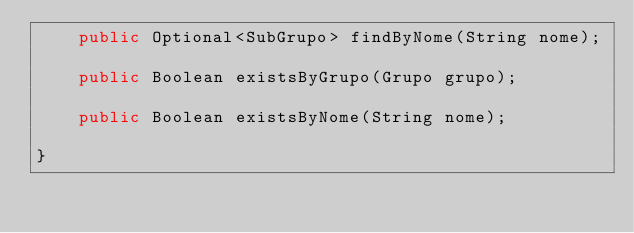<code> <loc_0><loc_0><loc_500><loc_500><_Java_>    public Optional<SubGrupo> findByNome(String nome);

    public Boolean existsByGrupo(Grupo grupo);

    public Boolean existsByNome(String nome);

}
</code> 